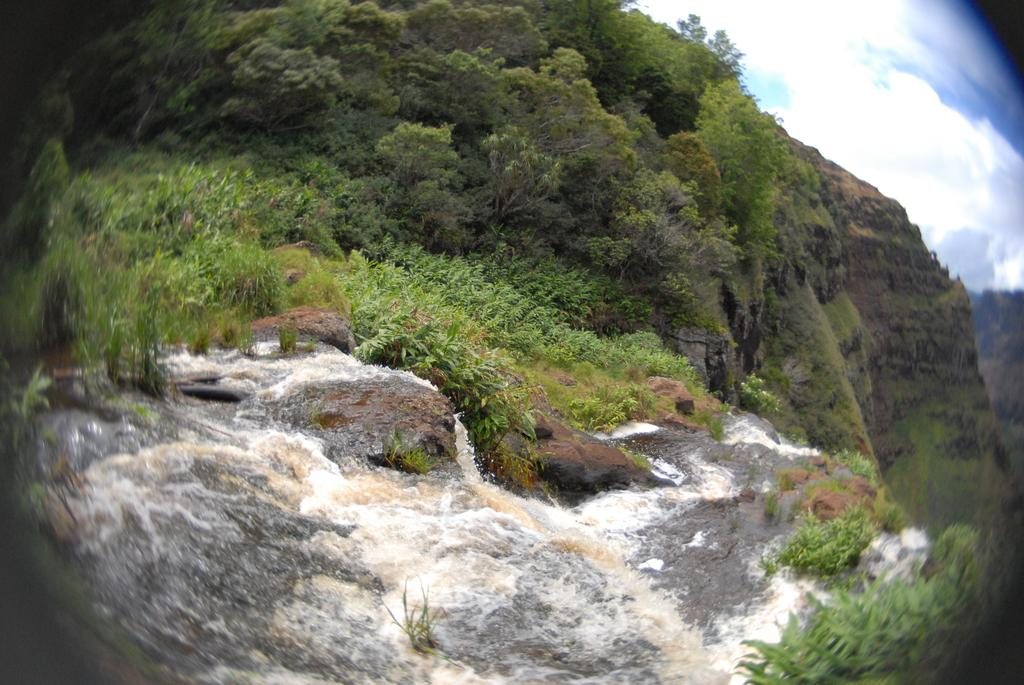What is visible in the front of the image? There is water in the front of the image. What can be seen in the background of the image? There are trees and mountains in the background of the image. What is the condition of the sky in the image? The sky is cloudy in the image. How does the parent help the child with their throat in the image? There is no parent or child present in the image, and therefore no such interaction can be observed. What type of balance is required to navigate the terrain in the image? There is no indication of terrain or any need for balance in the image, as it primarily features water, trees, mountains, and a cloudy sky. 